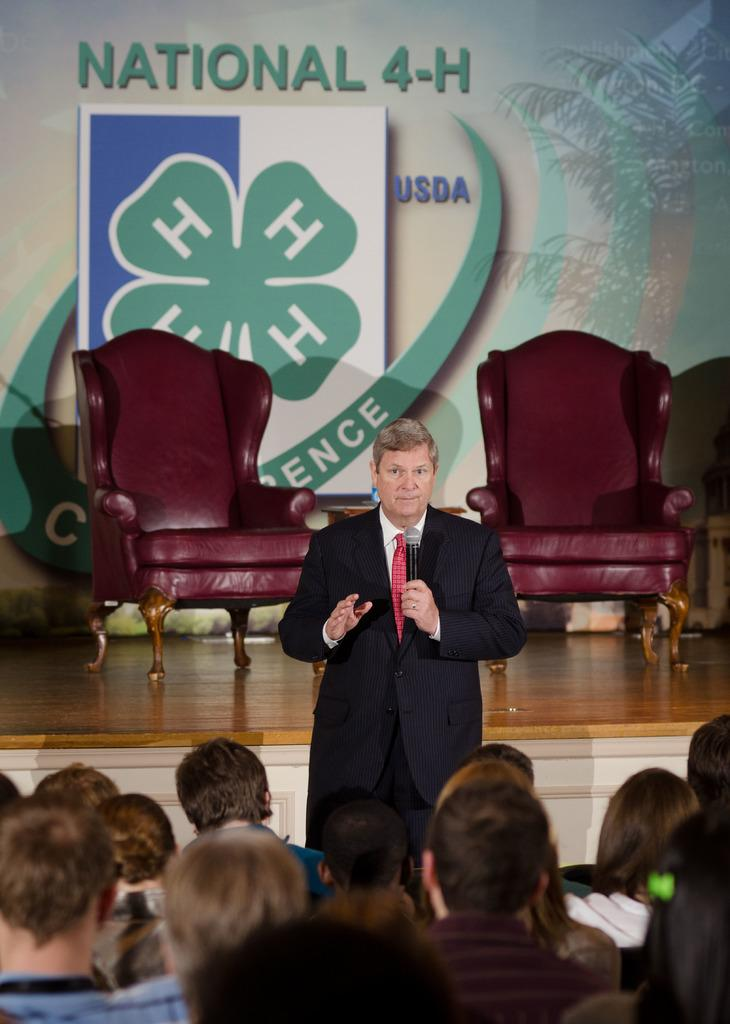Who is the main subject in the image? There is a man in the image. What is the man doing in the image? The man is standing and holding a mic in his hand. Who else is present in the image besides the man? There is a group of people in the image. What are the group of people doing in the image? The group of people are listening to the man. What type of lunch is the man eating in the image? There is no lunch present in the image; the man is holding a mic and standing in front of a group of people. 